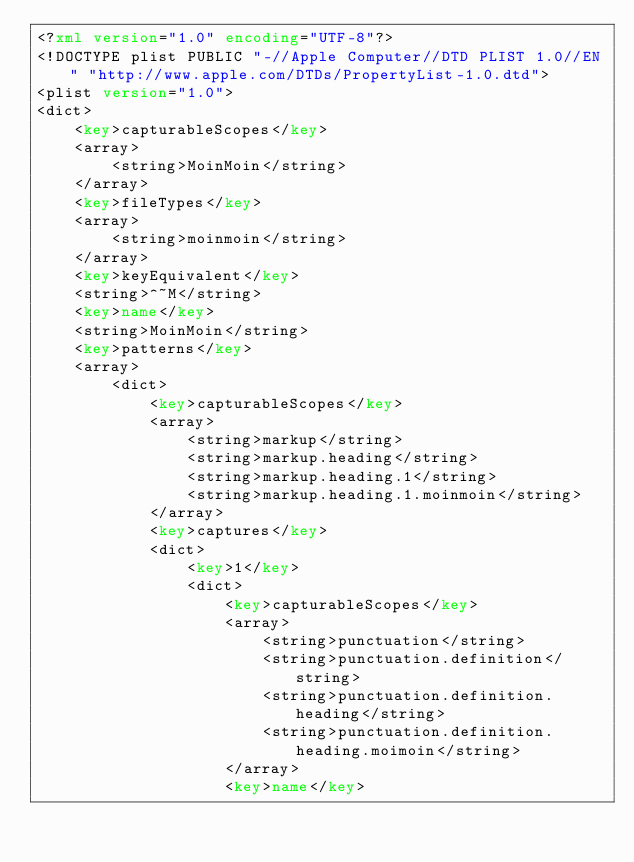Convert code to text. <code><loc_0><loc_0><loc_500><loc_500><_XML_><?xml version="1.0" encoding="UTF-8"?>
<!DOCTYPE plist PUBLIC "-//Apple Computer//DTD PLIST 1.0//EN" "http://www.apple.com/DTDs/PropertyList-1.0.dtd">
<plist version="1.0">
<dict>
	<key>capturableScopes</key>
	<array>
		<string>MoinMoin</string>
	</array>
	<key>fileTypes</key>
	<array>
		<string>moinmoin</string>
	</array>
	<key>keyEquivalent</key>
	<string>^~M</string>
	<key>name</key>
	<string>MoinMoin</string>
	<key>patterns</key>
	<array>
		<dict>
			<key>capturableScopes</key>
			<array>
				<string>markup</string>
				<string>markup.heading</string>
				<string>markup.heading.1</string>
				<string>markup.heading.1.moinmoin</string>
			</array>
			<key>captures</key>
			<dict>
				<key>1</key>
				<dict>
					<key>capturableScopes</key>
					<array>
						<string>punctuation</string>
						<string>punctuation.definition</string>
						<string>punctuation.definition.heading</string>
						<string>punctuation.definition.heading.moimoin</string>
					</array>
					<key>name</key></code> 